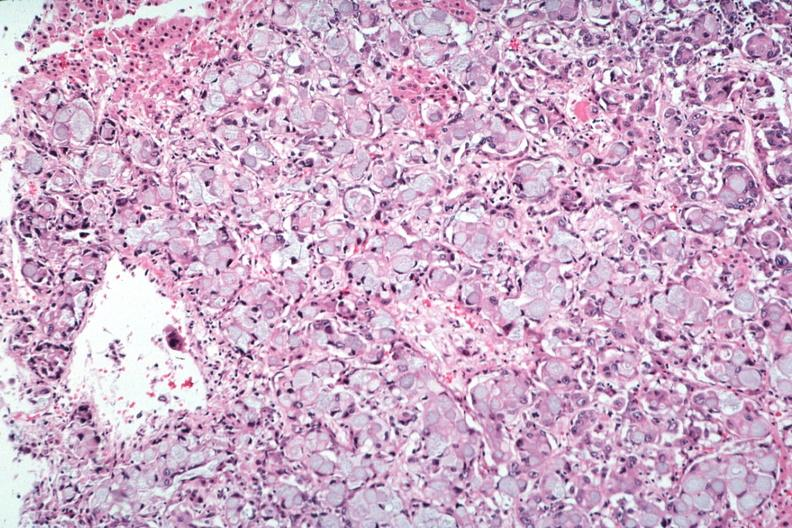does this image show primary in stomach?
Answer the question using a single word or phrase. Yes 